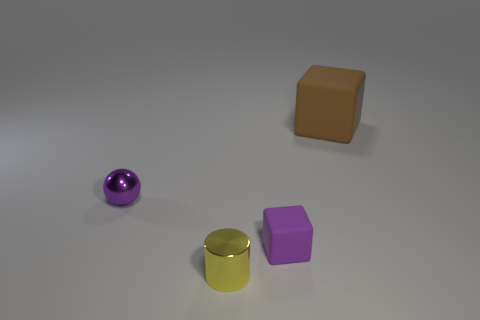Subtract all purple cubes. How many cubes are left? 1 Subtract all cylinders. How many objects are left? 3 Subtract 1 cylinders. How many cylinders are left? 0 Subtract all matte objects. Subtract all blue matte cubes. How many objects are left? 2 Add 2 small shiny cylinders. How many small shiny cylinders are left? 3 Add 2 large things. How many large things exist? 3 Add 1 purple things. How many objects exist? 5 Subtract 1 purple blocks. How many objects are left? 3 Subtract all gray balls. Subtract all green cylinders. How many balls are left? 1 Subtract all purple spheres. How many brown cubes are left? 1 